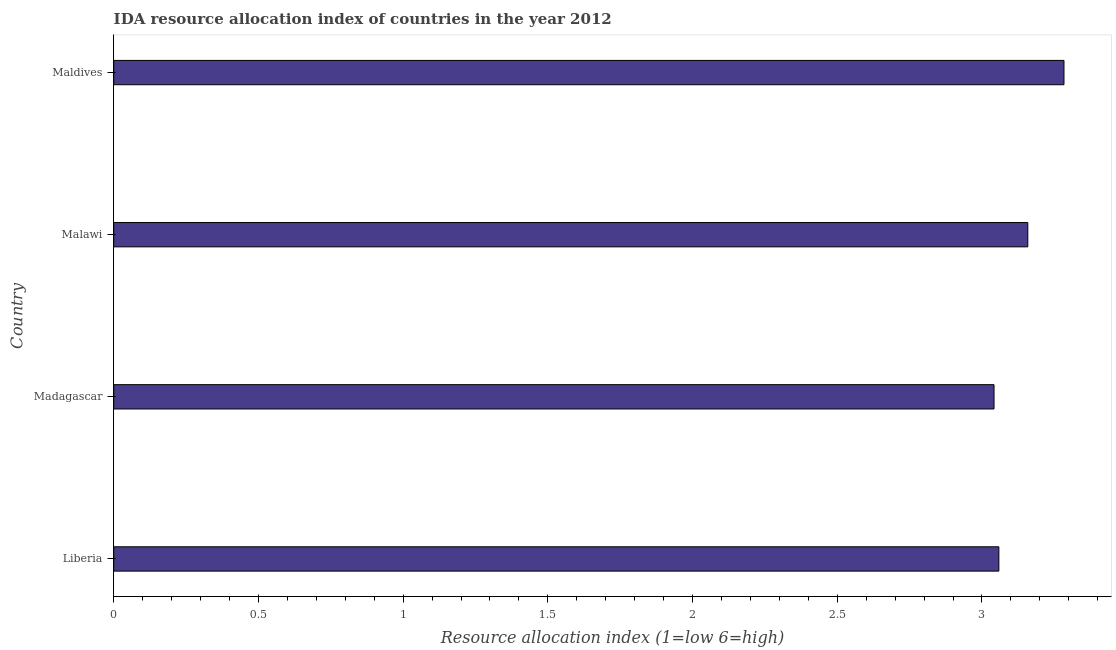What is the title of the graph?
Your answer should be very brief. IDA resource allocation index of countries in the year 2012. What is the label or title of the X-axis?
Provide a short and direct response. Resource allocation index (1=low 6=high). What is the ida resource allocation index in Liberia?
Ensure brevity in your answer.  3.06. Across all countries, what is the maximum ida resource allocation index?
Give a very brief answer. 3.28. Across all countries, what is the minimum ida resource allocation index?
Give a very brief answer. 3.04. In which country was the ida resource allocation index maximum?
Keep it short and to the point. Maldives. In which country was the ida resource allocation index minimum?
Offer a very short reply. Madagascar. What is the sum of the ida resource allocation index?
Your answer should be compact. 12.54. What is the difference between the ida resource allocation index in Malawi and Maldives?
Your answer should be very brief. -0.12. What is the average ida resource allocation index per country?
Your response must be concise. 3.13. What is the median ida resource allocation index?
Give a very brief answer. 3.11. In how many countries, is the ida resource allocation index greater than 0.9 ?
Your answer should be compact. 4. Is the difference between the ida resource allocation index in Madagascar and Malawi greater than the difference between any two countries?
Provide a succinct answer. No. What is the difference between the highest and the second highest ida resource allocation index?
Provide a succinct answer. 0.12. Is the sum of the ida resource allocation index in Madagascar and Malawi greater than the maximum ida resource allocation index across all countries?
Provide a succinct answer. Yes. What is the difference between the highest and the lowest ida resource allocation index?
Ensure brevity in your answer.  0.24. How many bars are there?
Your answer should be very brief. 4. What is the Resource allocation index (1=low 6=high) of Liberia?
Your answer should be compact. 3.06. What is the Resource allocation index (1=low 6=high) in Madagascar?
Your answer should be compact. 3.04. What is the Resource allocation index (1=low 6=high) in Malawi?
Provide a succinct answer. 3.16. What is the Resource allocation index (1=low 6=high) in Maldives?
Offer a very short reply. 3.28. What is the difference between the Resource allocation index (1=low 6=high) in Liberia and Madagascar?
Provide a short and direct response. 0.02. What is the difference between the Resource allocation index (1=low 6=high) in Liberia and Maldives?
Keep it short and to the point. -0.23. What is the difference between the Resource allocation index (1=low 6=high) in Madagascar and Malawi?
Keep it short and to the point. -0.12. What is the difference between the Resource allocation index (1=low 6=high) in Madagascar and Maldives?
Keep it short and to the point. -0.24. What is the difference between the Resource allocation index (1=low 6=high) in Malawi and Maldives?
Offer a very short reply. -0.12. What is the ratio of the Resource allocation index (1=low 6=high) in Liberia to that in Madagascar?
Make the answer very short. 1. What is the ratio of the Resource allocation index (1=low 6=high) in Liberia to that in Malawi?
Offer a terse response. 0.97. What is the ratio of the Resource allocation index (1=low 6=high) in Madagascar to that in Maldives?
Offer a very short reply. 0.93. 